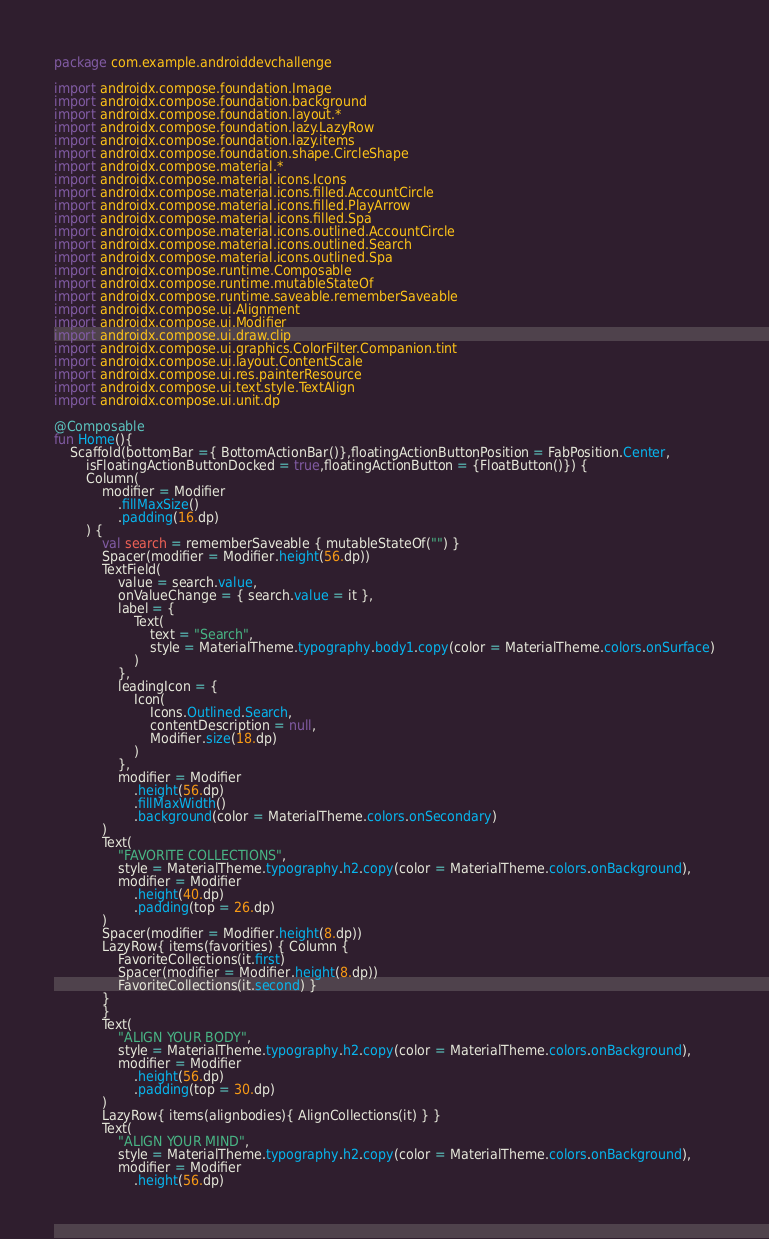Convert code to text. <code><loc_0><loc_0><loc_500><loc_500><_Kotlin_>package com.example.androiddevchallenge

import androidx.compose.foundation.Image
import androidx.compose.foundation.background
import androidx.compose.foundation.layout.*
import androidx.compose.foundation.lazy.LazyRow
import androidx.compose.foundation.lazy.items
import androidx.compose.foundation.shape.CircleShape
import androidx.compose.material.*
import androidx.compose.material.icons.Icons
import androidx.compose.material.icons.filled.AccountCircle
import androidx.compose.material.icons.filled.PlayArrow
import androidx.compose.material.icons.filled.Spa
import androidx.compose.material.icons.outlined.AccountCircle
import androidx.compose.material.icons.outlined.Search
import androidx.compose.material.icons.outlined.Spa
import androidx.compose.runtime.Composable
import androidx.compose.runtime.mutableStateOf
import androidx.compose.runtime.saveable.rememberSaveable
import androidx.compose.ui.Alignment
import androidx.compose.ui.Modifier
import androidx.compose.ui.draw.clip
import androidx.compose.ui.graphics.ColorFilter.Companion.tint
import androidx.compose.ui.layout.ContentScale
import androidx.compose.ui.res.painterResource
import androidx.compose.ui.text.style.TextAlign
import androidx.compose.ui.unit.dp

@Composable
fun Home(){
    Scaffold(bottomBar ={ BottomActionBar()},floatingActionButtonPosition = FabPosition.Center,
        isFloatingActionButtonDocked = true,floatingActionButton = {FloatButton()}) {
        Column(
            modifier = Modifier
                .fillMaxSize()
                .padding(16.dp)
        ) {
            val search = rememberSaveable { mutableStateOf("") }
            Spacer(modifier = Modifier.height(56.dp))
            TextField(
                value = search.value,
                onValueChange = { search.value = it },
                label = {
                    Text(
                        text = "Search",
                        style = MaterialTheme.typography.body1.copy(color = MaterialTheme.colors.onSurface)
                    )
                },
                leadingIcon = {
                    Icon(
                        Icons.Outlined.Search,
                        contentDescription = null,
                        Modifier.size(18.dp)
                    )
                },
                modifier = Modifier
                    .height(56.dp)
                    .fillMaxWidth()
                    .background(color = MaterialTheme.colors.onSecondary)
            )
            Text(
                "FAVORITE COLLECTIONS",
                style = MaterialTheme.typography.h2.copy(color = MaterialTheme.colors.onBackground),
                modifier = Modifier
                    .height(40.dp)
                    .padding(top = 26.dp)
            )
            Spacer(modifier = Modifier.height(8.dp))
            LazyRow{ items(favorities) { Column {
                FavoriteCollections(it.first)
                Spacer(modifier = Modifier.height(8.dp))
                FavoriteCollections(it.second) }
            }
            }
            Text(
                "ALIGN YOUR BODY",
                style = MaterialTheme.typography.h2.copy(color = MaterialTheme.colors.onBackground),
                modifier = Modifier
                    .height(56.dp)
                    .padding(top = 30.dp)
            )
            LazyRow{ items(alignbodies){ AlignCollections(it) } }
            Text(
                "ALIGN YOUR MIND",
                style = MaterialTheme.typography.h2.copy(color = MaterialTheme.colors.onBackground),
                modifier = Modifier
                    .height(56.dp)</code> 